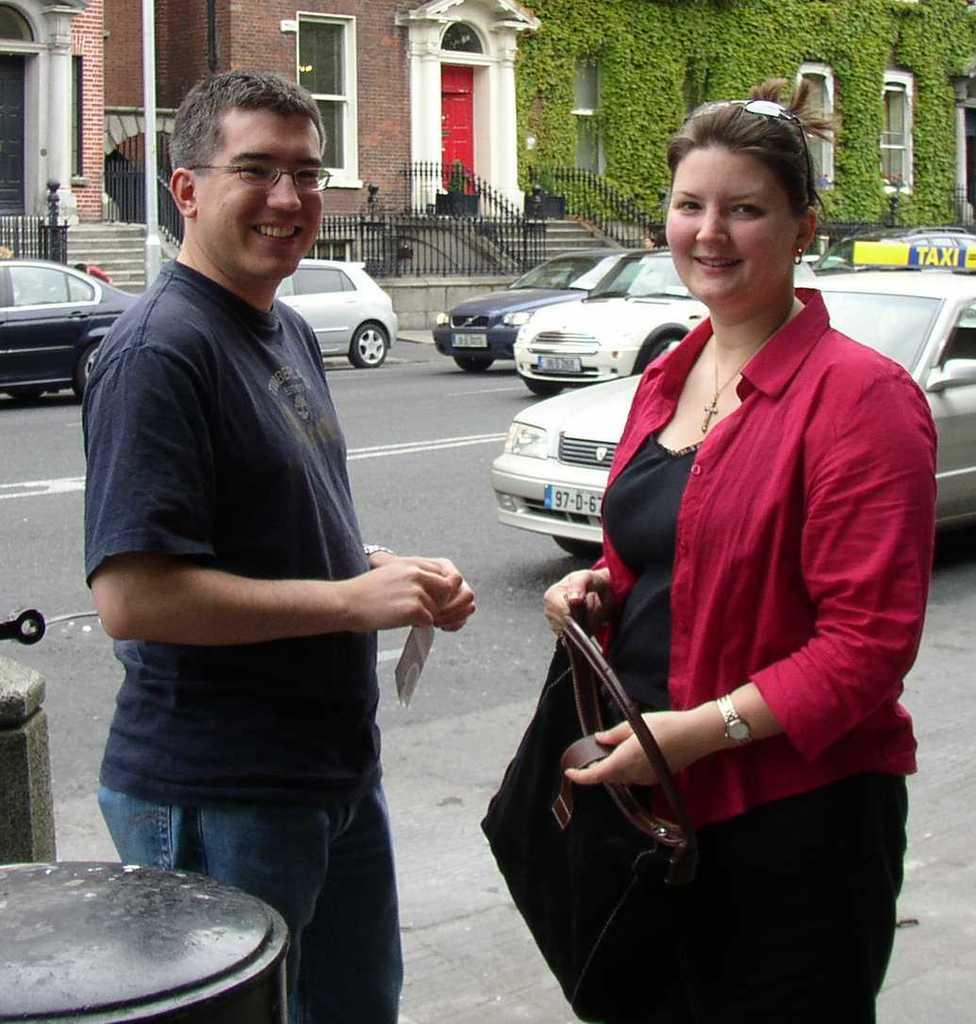What can be seen on the road in the image? There are vehicles on the road in the image. What are the man and woman doing in the image? The man and woman are talking in the image. What is the woman holding in the image? The woman is holding a bag in the image. What type of structures can be seen in the image? There are buildings visible in the image. What type of vegetation is present in the image? There is grass in the image. Where is the shelf located in the image? There is no shelf present in the image. What type of office can be seen in the image? There is no office present in the image. 